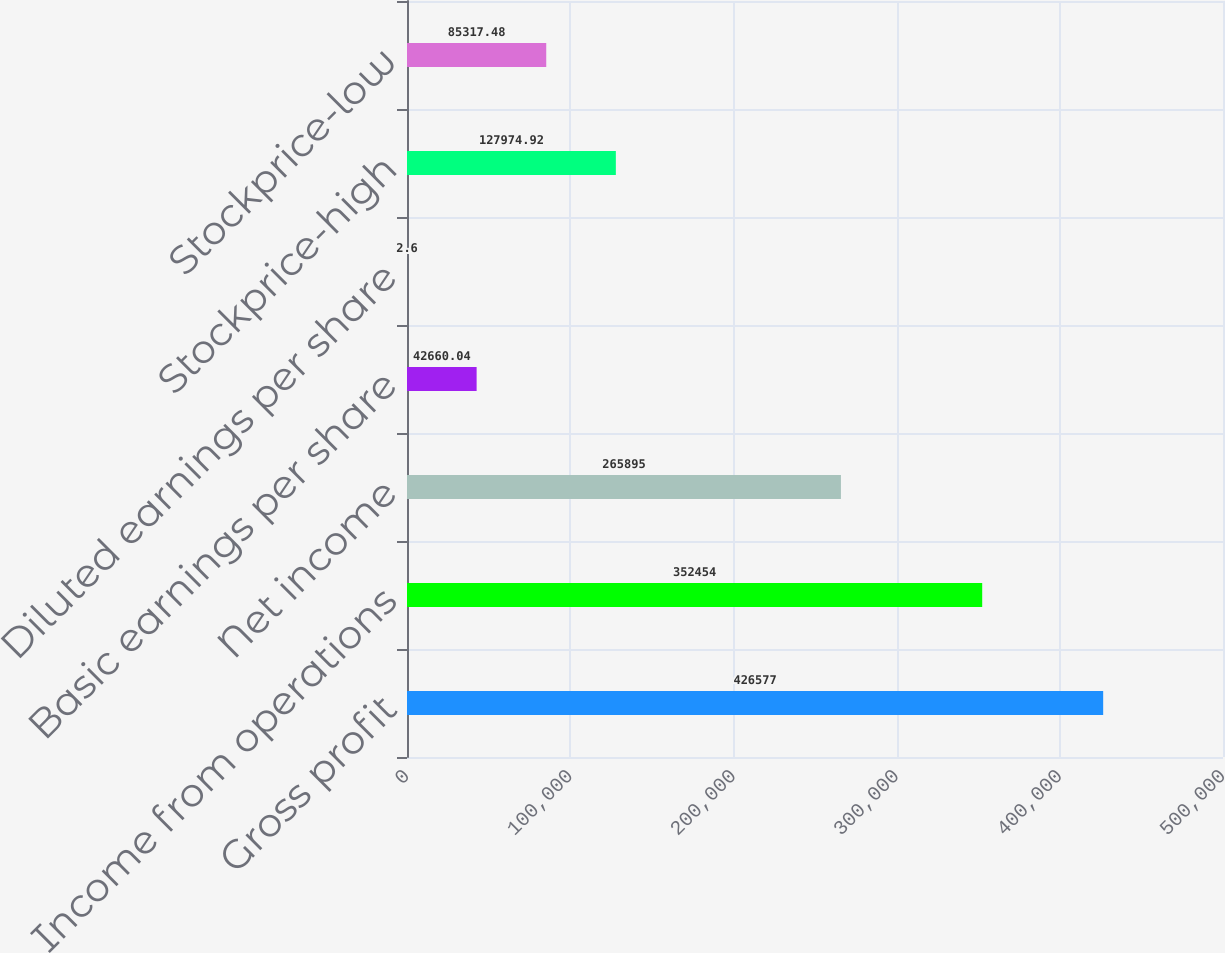Convert chart to OTSL. <chart><loc_0><loc_0><loc_500><loc_500><bar_chart><fcel>Gross profit<fcel>Income from operations<fcel>Net income<fcel>Basic earnings per share<fcel>Diluted earnings per share<fcel>Stockprice-high<fcel>Stockprice-low<nl><fcel>426577<fcel>352454<fcel>265895<fcel>42660<fcel>2.6<fcel>127975<fcel>85317.5<nl></chart> 